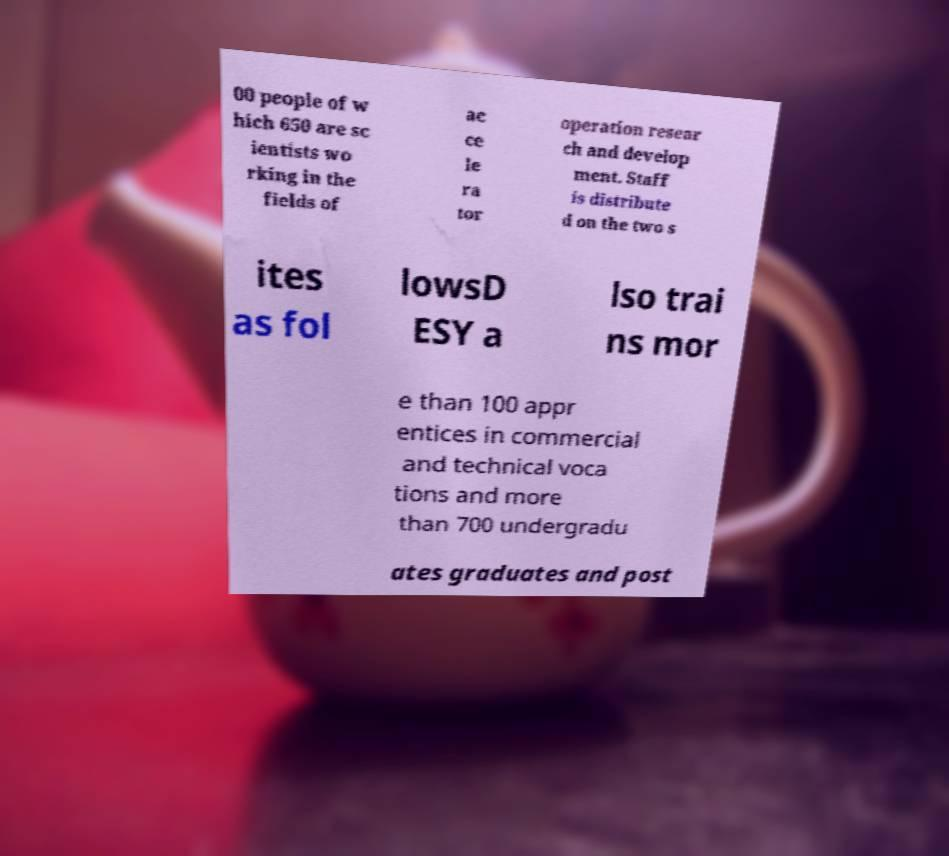Can you accurately transcribe the text from the provided image for me? 00 people of w hich 650 are sc ientists wo rking in the fields of ac ce le ra tor operation resear ch and develop ment. Staff is distribute d on the two s ites as fol lowsD ESY a lso trai ns mor e than 100 appr entices in commercial and technical voca tions and more than 700 undergradu ates graduates and post 